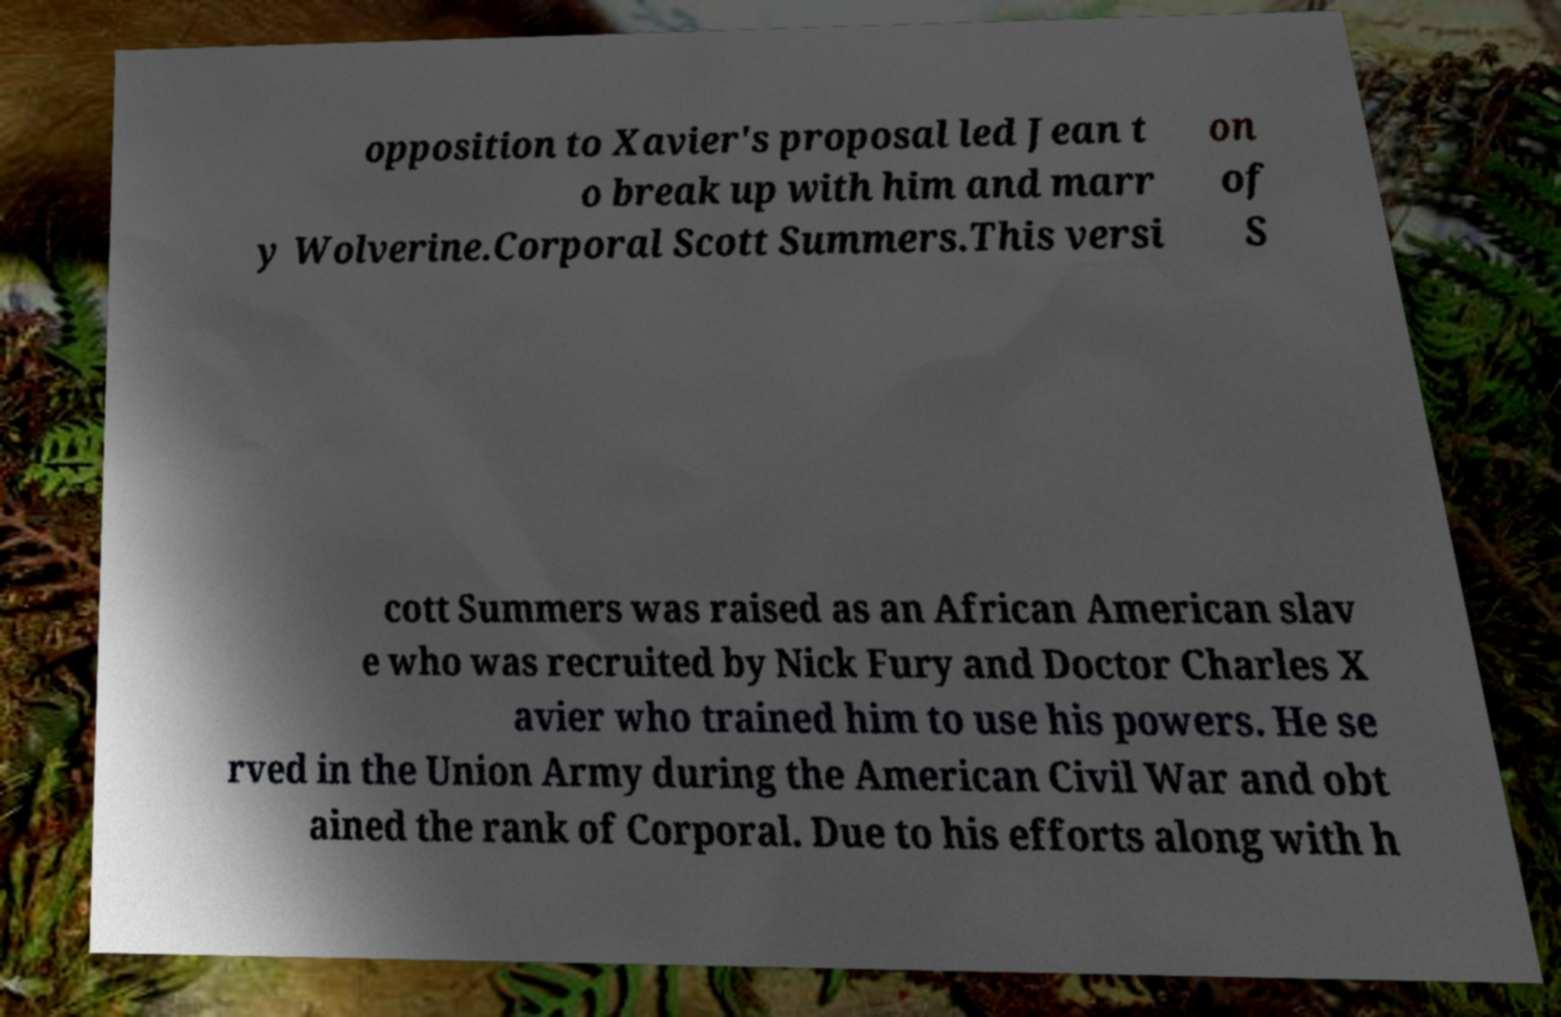Could you extract and type out the text from this image? opposition to Xavier's proposal led Jean t o break up with him and marr y Wolverine.Corporal Scott Summers.This versi on of S cott Summers was raised as an African American slav e who was recruited by Nick Fury and Doctor Charles X avier who trained him to use his powers. He se rved in the Union Army during the American Civil War and obt ained the rank of Corporal. Due to his efforts along with h 